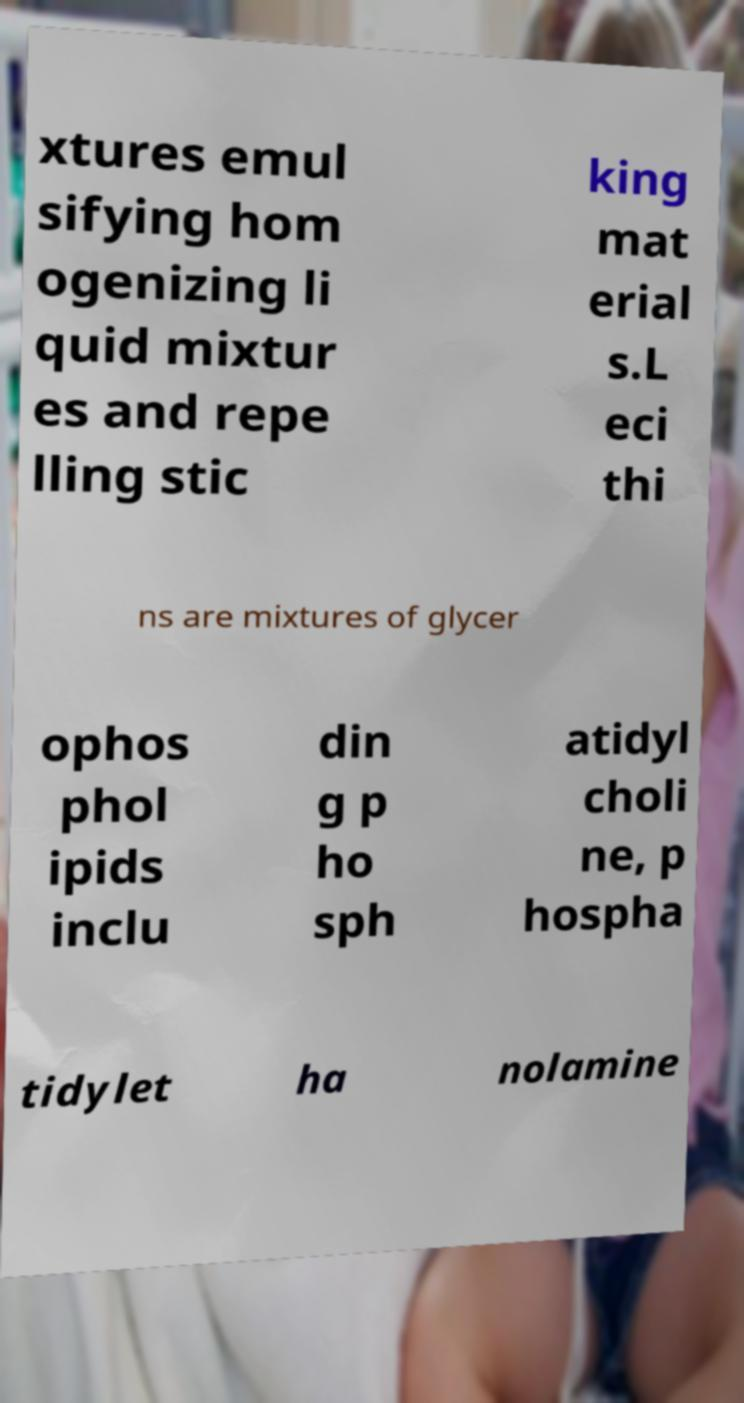Please read and relay the text visible in this image. What does it say? xtures emul sifying hom ogenizing li quid mixtur es and repe lling stic king mat erial s.L eci thi ns are mixtures of glycer ophos phol ipids inclu din g p ho sph atidyl choli ne, p hospha tidylet ha nolamine 